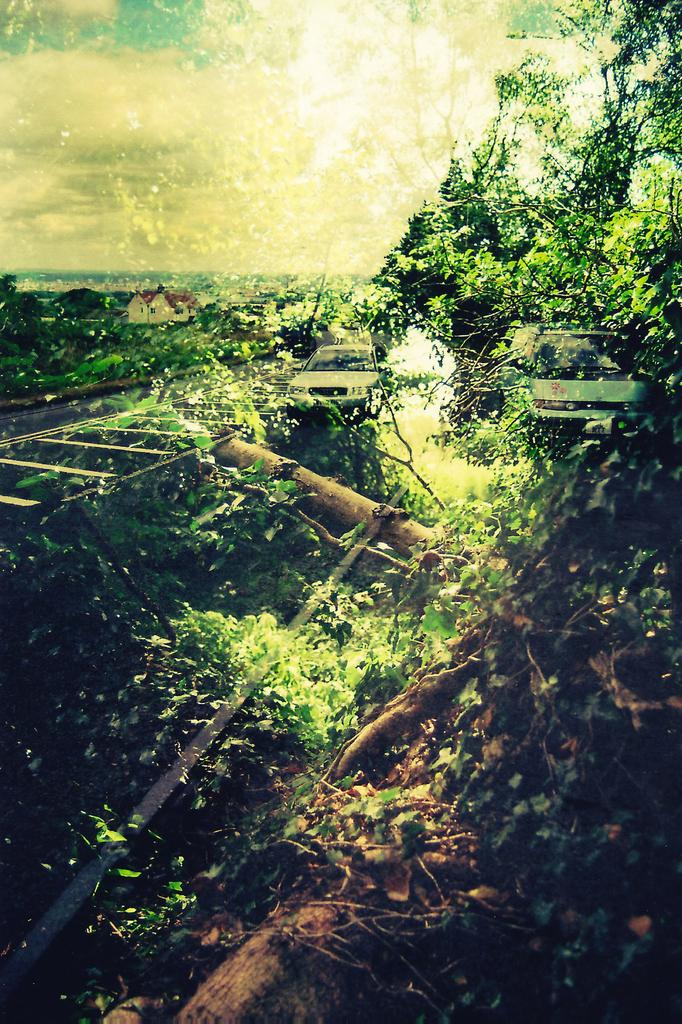What is the main subject of the image? The main subject of the image is a picture with a reflection. What can be seen in the reflection? The reflection includes plants and trees. How many cars are visible in the image? There are two cars in the image. What is located on the left side of the image? There is a building on the left side of the image. What is the condition of the sky in the image? The sky is clear in the image. Can you tell me how many rail tracks are visible in the image? There are no rail tracks present in the image. What type of trains can be seen passing by the building in the image? There are no trains visible in the image; only two cars and a building are present. 